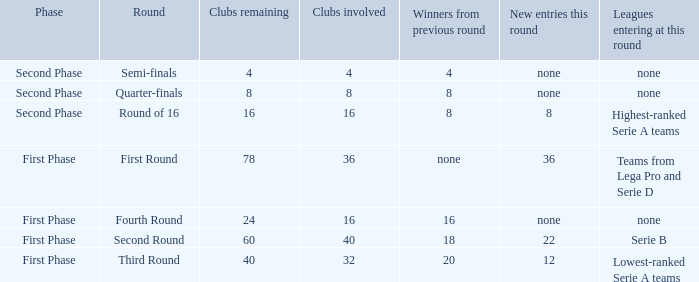When looking at new entries this round and seeing 8; what number in total is there for clubs remaining? 1.0. 